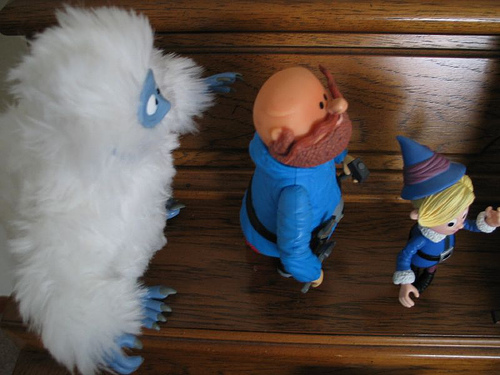<image>
Can you confirm if the toy is in front of the doll? Yes. The toy is positioned in front of the doll, appearing closer to the camera viewpoint. 